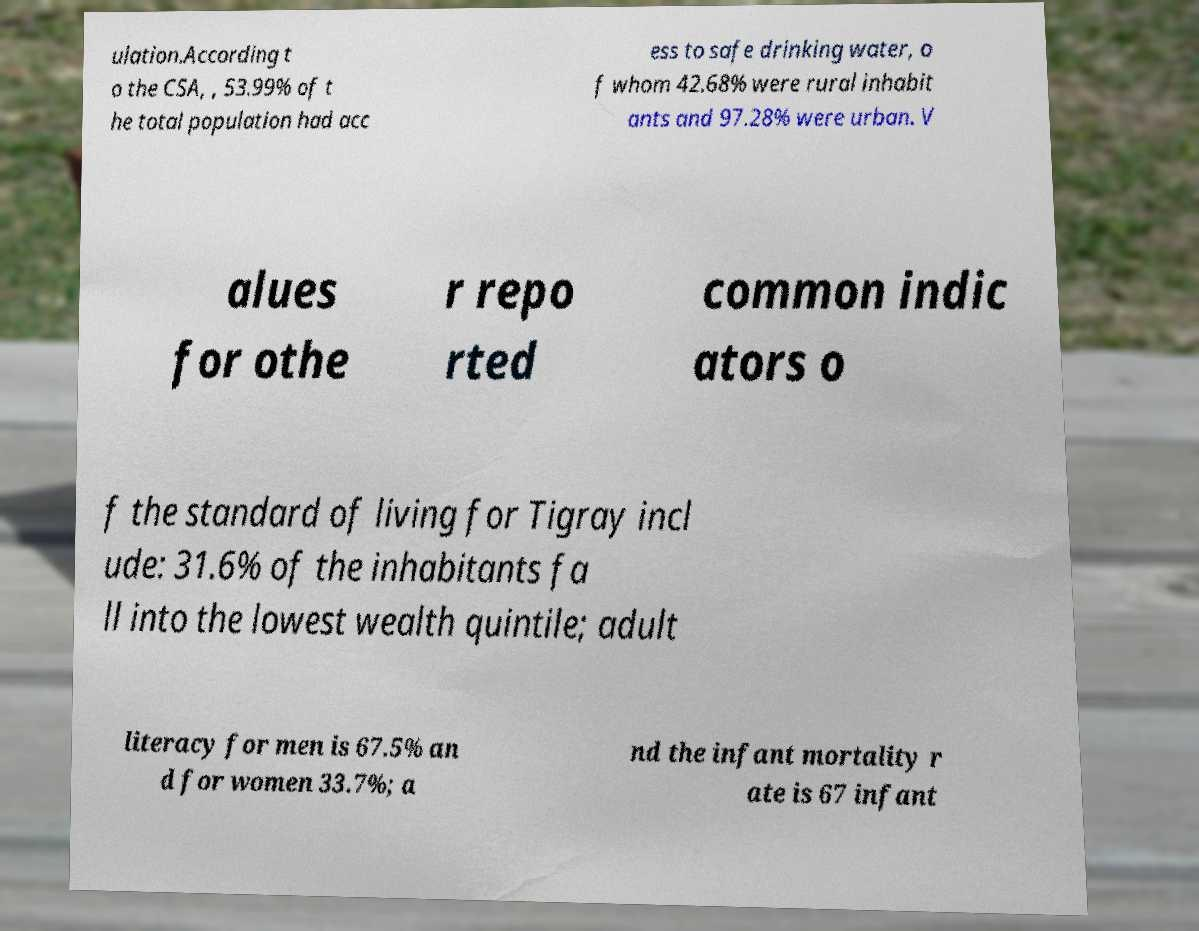Please identify and transcribe the text found in this image. ulation.According t o the CSA, , 53.99% of t he total population had acc ess to safe drinking water, o f whom 42.68% were rural inhabit ants and 97.28% were urban. V alues for othe r repo rted common indic ators o f the standard of living for Tigray incl ude: 31.6% of the inhabitants fa ll into the lowest wealth quintile; adult literacy for men is 67.5% an d for women 33.7%; a nd the infant mortality r ate is 67 infant 